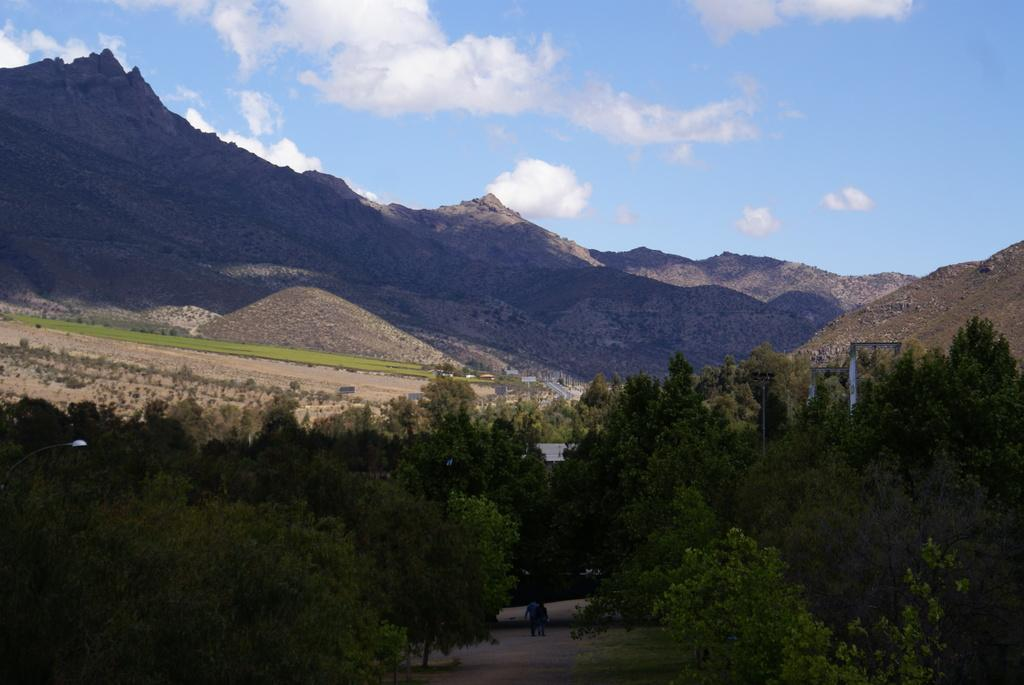What type of vegetation is present at the bottom of the image? There are trees at the bottom of the image. What type of man-made structure is present at the bottom of the image? There is a street light at the bottom of the image. What other objects can be seen at the bottom of the image? There are poles and boards at the bottom of the image. What are the people in the image doing? There are people on a walkway at the bottom of the image. What can be seen in the background of the image? There are hills, trees, and a cloudy sky in the background of the image. What is the taste of the street light in the image? Street lights do not have a taste, as they are not edible objects. Can you confirm the existence of a tent in the image? There is no mention of a tent in the provided facts, and therefore it cannot be confirmed that a tent is present in the image. 